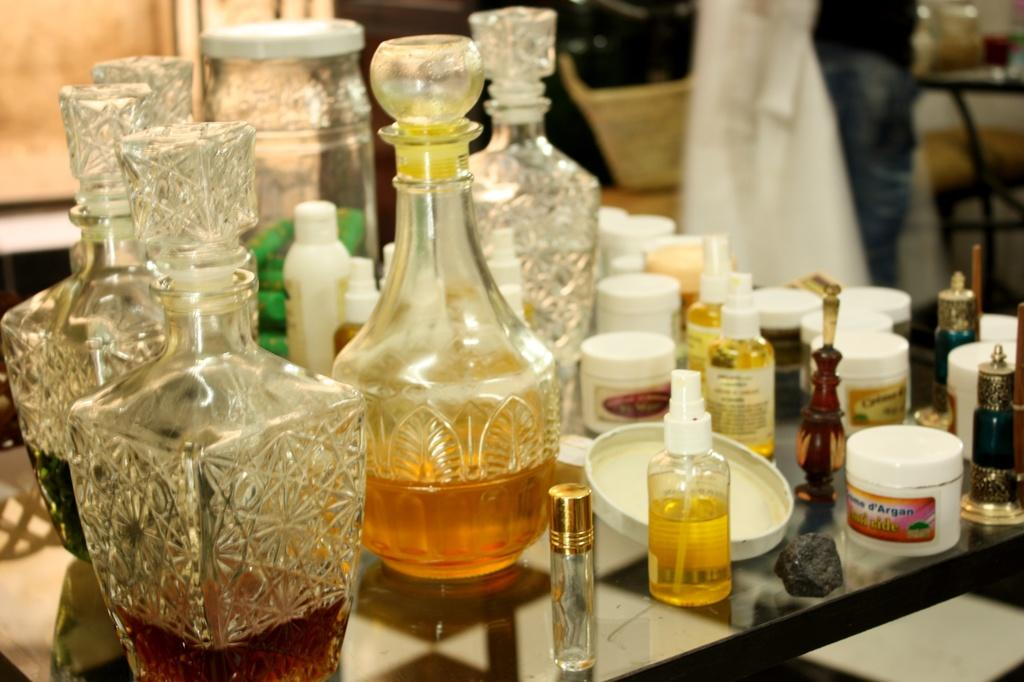<image>
Offer a succinct explanation of the picture presented. A small container says d'Argan on the label. 